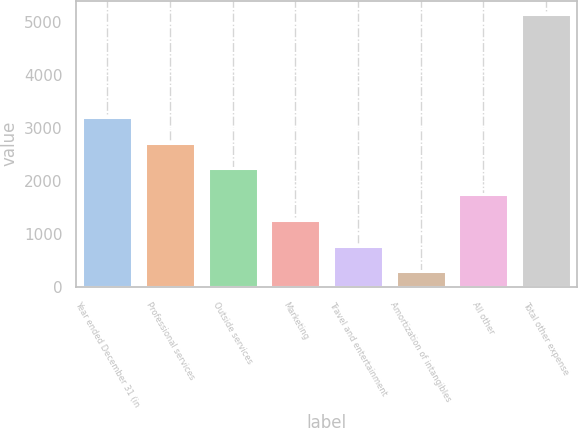Convert chart to OTSL. <chart><loc_0><loc_0><loc_500><loc_500><bar_chart><fcel>Year ended December 31 (in<fcel>Professional services<fcel>Outside services<fcel>Marketing<fcel>Travel and entertainment<fcel>Amortization of intangibles<fcel>All other<fcel>Total other expense<nl><fcel>3199.8<fcel>2715.5<fcel>2231.2<fcel>1262.6<fcel>778.3<fcel>294<fcel>1746.9<fcel>5137<nl></chart> 